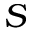Convert formula to latex. <formula><loc_0><loc_0><loc_500><loc_500>S</formula> 